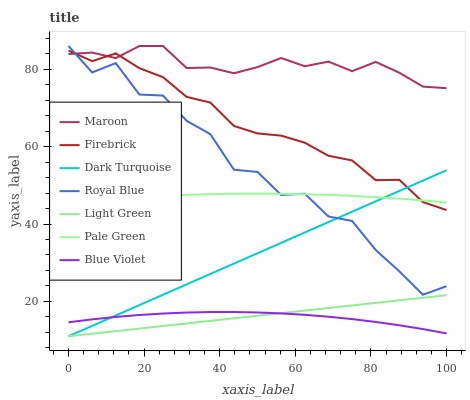Does Blue Violet have the minimum area under the curve?
Answer yes or no. Yes. Does Maroon have the maximum area under the curve?
Answer yes or no. Yes. Does Firebrick have the minimum area under the curve?
Answer yes or no. No. Does Firebrick have the maximum area under the curve?
Answer yes or no. No. Is Light Green the smoothest?
Answer yes or no. Yes. Is Royal Blue the roughest?
Answer yes or no. Yes. Is Firebrick the smoothest?
Answer yes or no. No. Is Firebrick the roughest?
Answer yes or no. No. Does Firebrick have the lowest value?
Answer yes or no. No. Does Firebrick have the highest value?
Answer yes or no. No. Is Blue Violet less than Firebrick?
Answer yes or no. Yes. Is Maroon greater than Blue Violet?
Answer yes or no. Yes. Does Blue Violet intersect Firebrick?
Answer yes or no. No. 